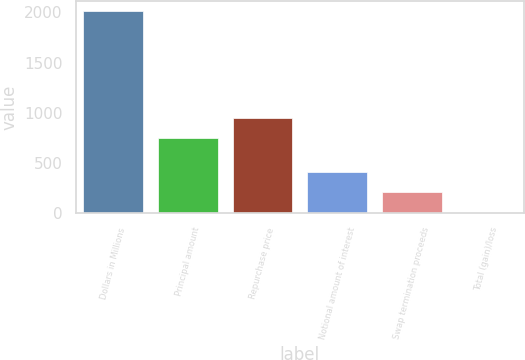Convert chart to OTSL. <chart><loc_0><loc_0><loc_500><loc_500><bar_chart><fcel>Dollars in Millions<fcel>Principal amount<fcel>Repurchase price<fcel>Notional amount of interest<fcel>Swap termination proceeds<fcel>Total (gain)/loss<nl><fcel>2010<fcel>750<fcel>950.4<fcel>406.8<fcel>206.4<fcel>6<nl></chart> 